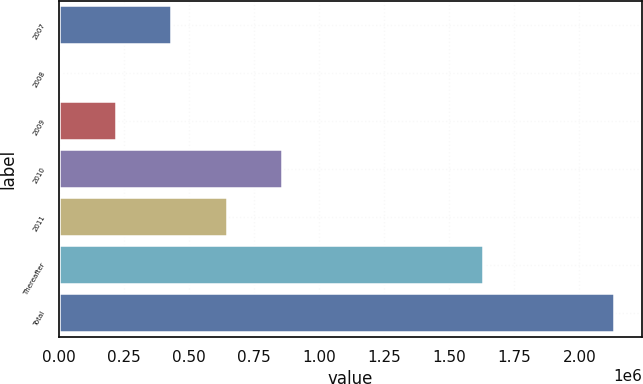Convert chart to OTSL. <chart><loc_0><loc_0><loc_500><loc_500><bar_chart><fcel>2007<fcel>2008<fcel>2009<fcel>2010<fcel>2011<fcel>Thereafter<fcel>Total<nl><fcel>430065<fcel>4010<fcel>217038<fcel>856120<fcel>643093<fcel>1.62973e+06<fcel>2.13429e+06<nl></chart> 